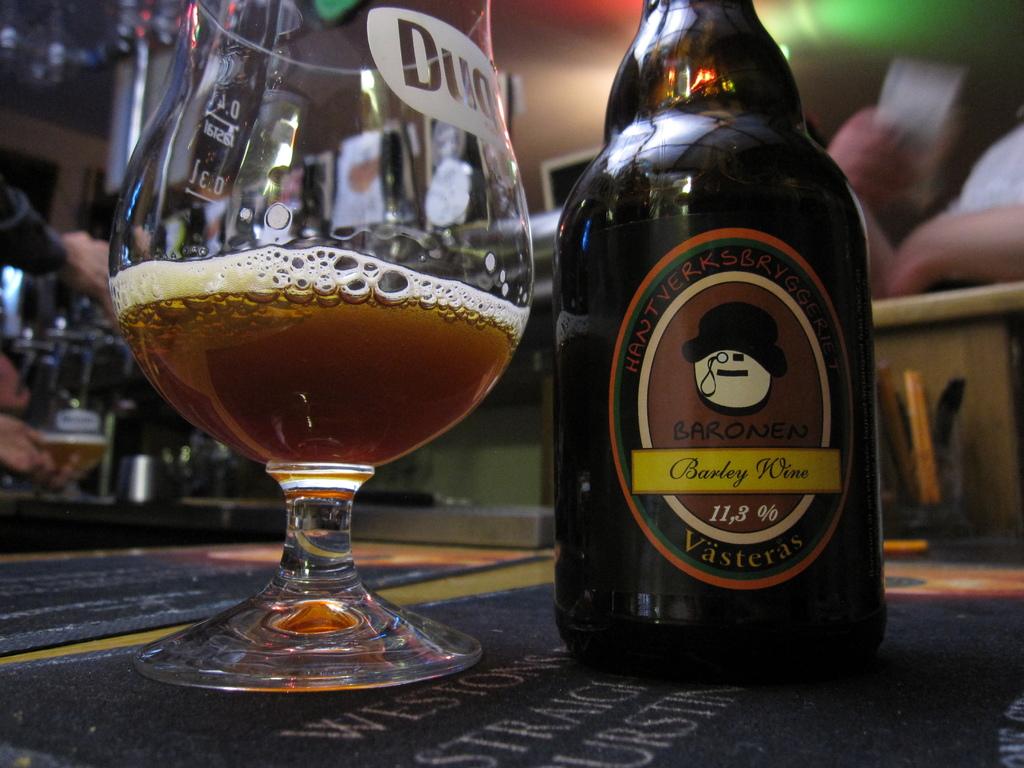What is the percentage of alcohol in this beverage?
Provide a short and direct response. 11.3. What wine is that?
Provide a succinct answer. Barley wine. 